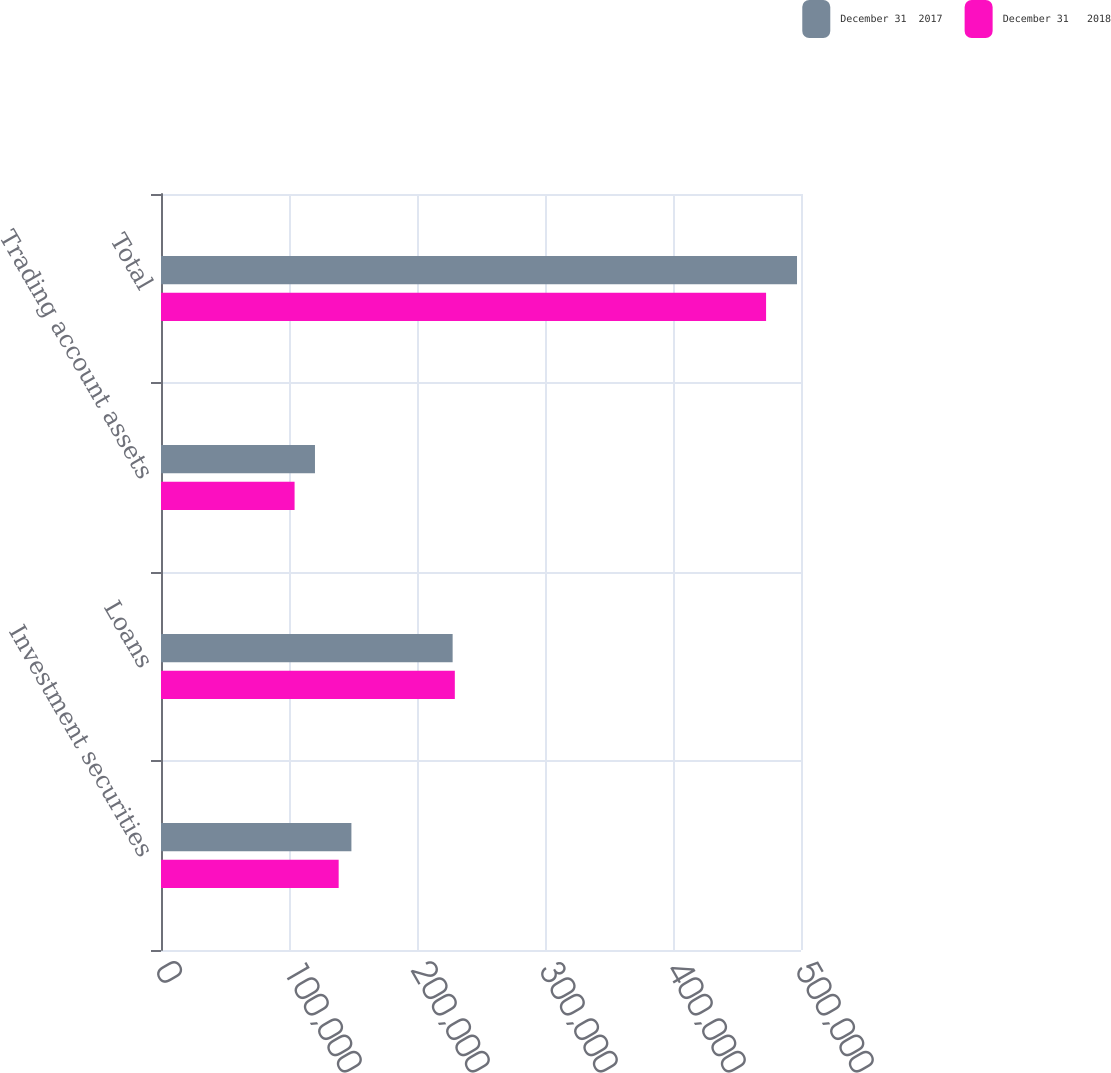Convert chart. <chart><loc_0><loc_0><loc_500><loc_500><stacked_bar_chart><ecel><fcel>Investment securities<fcel>Loans<fcel>Trading account assets<fcel>Total<nl><fcel>December 31  2017<fcel>148756<fcel>227840<fcel>120292<fcel>496888<nl><fcel>December 31   2018<fcel>138807<fcel>229552<fcel>104360<fcel>472719<nl></chart> 